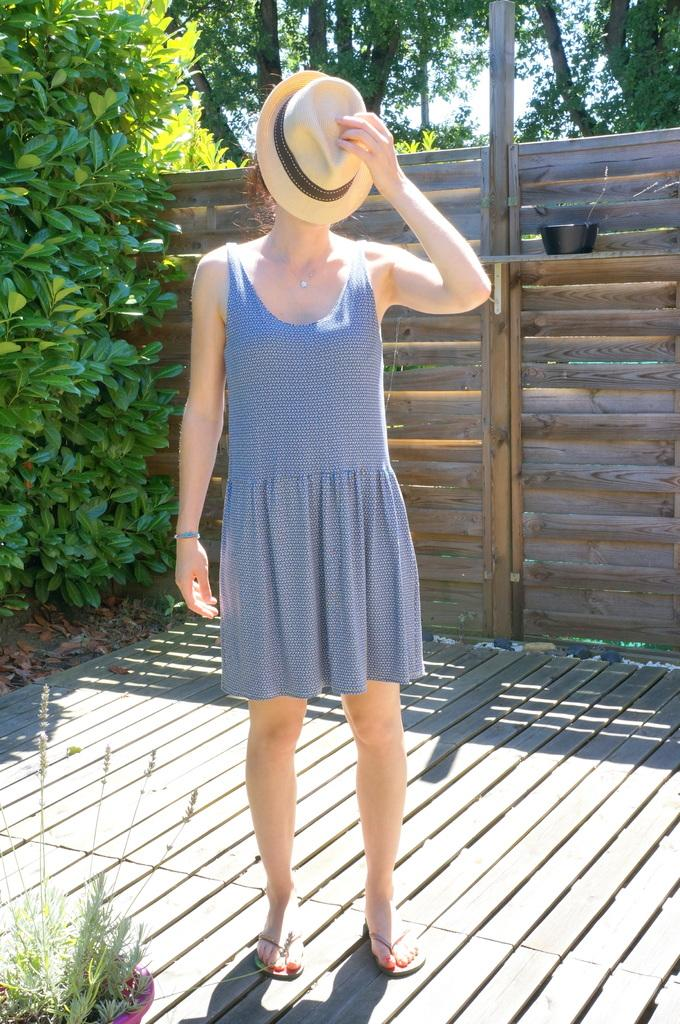What is the woman in the image doing? The woman is standing in the image. What is the woman holding in the image? The woman is holding a hat. What type of plant can be seen in the image? There is a house plant in the image. What can be seen in the background of the image? There is a fence, trees, and the sky visible in the background of the image. Where is the nest located in the image? There is no nest present in the image. What type of furniture can be seen in the image? There is no furniture present in the image. 